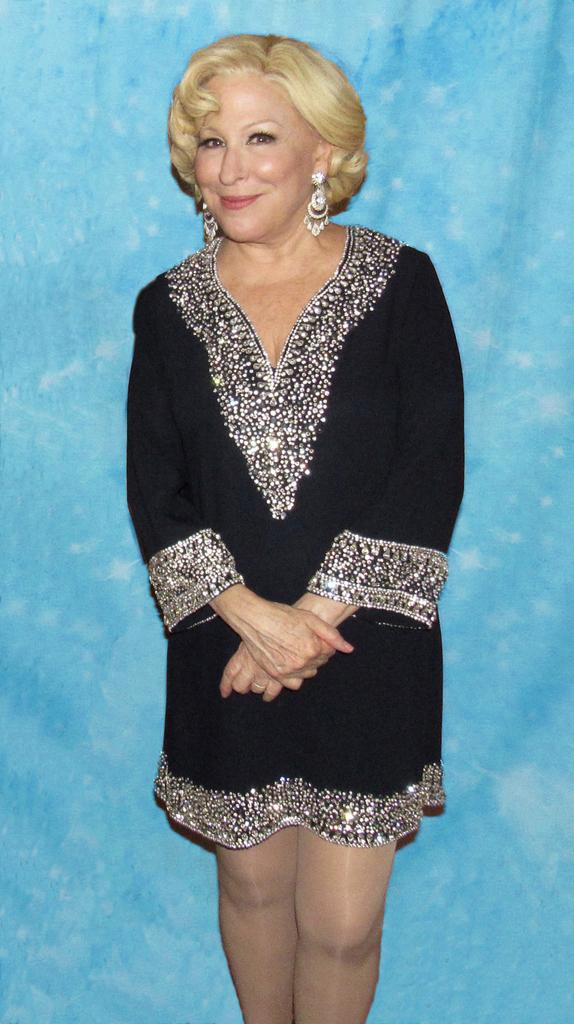Who is the main subject in the image? There is a woman in the image. What is the woman wearing? The woman is wearing a black dress. Can you describe the design on the black dress? The black dress has a design. What color is the background of the image? The background of the image is blue. What is the temper of the duck in the image? There is no duck present in the image, so it is not possible to determine its temper. 